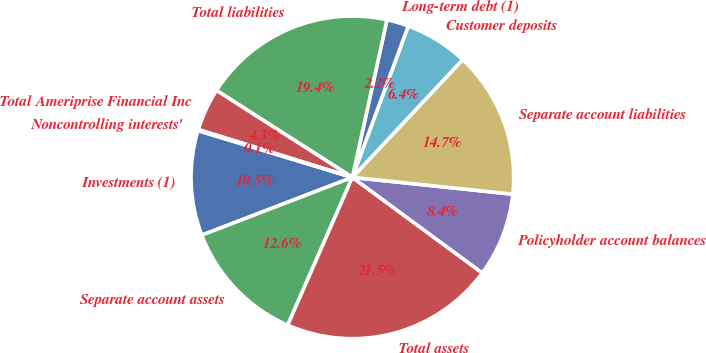Convert chart to OTSL. <chart><loc_0><loc_0><loc_500><loc_500><pie_chart><fcel>Investments (1)<fcel>Separate account assets<fcel>Total assets<fcel>Policyholder account balances<fcel>Separate account liabilities<fcel>Customer deposits<fcel>Long-term debt (1)<fcel>Total liabilities<fcel>Total Ameriprise Financial Inc<fcel>Noncontrolling interests'<nl><fcel>10.51%<fcel>12.6%<fcel>21.47%<fcel>8.43%<fcel>14.68%<fcel>6.35%<fcel>2.19%<fcel>19.38%<fcel>4.27%<fcel>0.11%<nl></chart> 